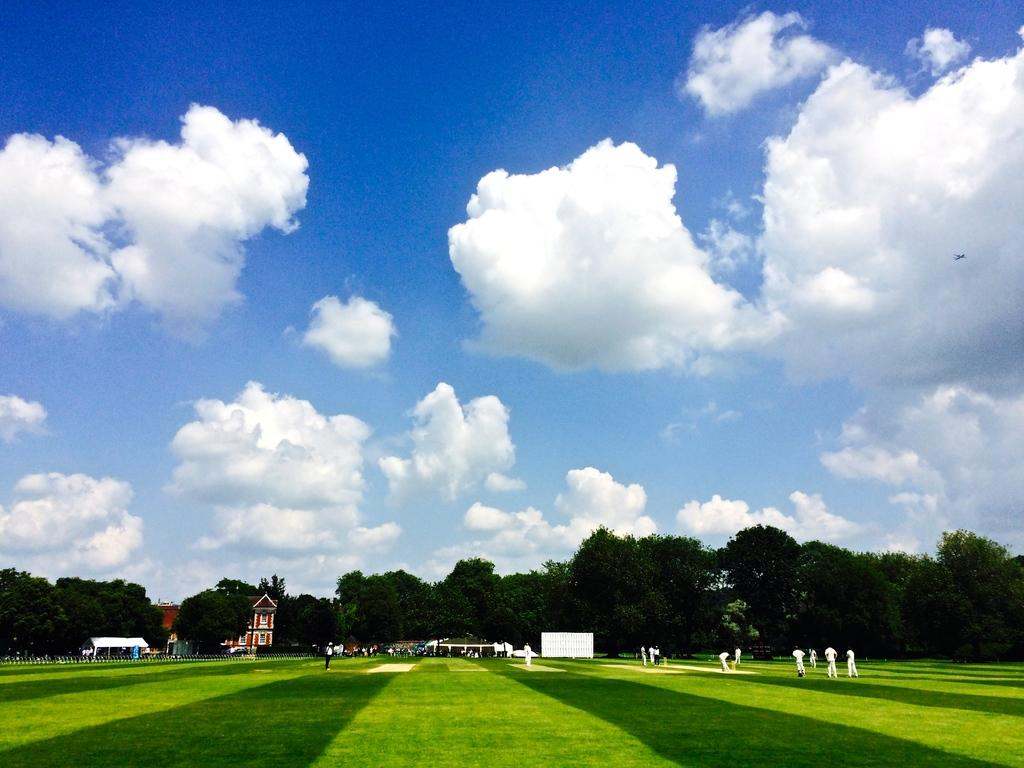What is the main setting of the image? The main setting of the image is a ground. What are the people in the image doing? There are many people playing on the ground in the image. What type of vegetation can be seen in the image? There are trees in the image. What structures are visible in the background of the image? There are buildings in the image. What is the condition of the sky in the image? The sky is clear in the image. What type of hose is being used by the people playing in the image? There is no hose present in the image; the people are playing on a ground without any visible hoses. What is the name of the industry that the buildings in the image belong to? There is no specific industry mentioned or implied in the image; the buildings are simply part of the background. 